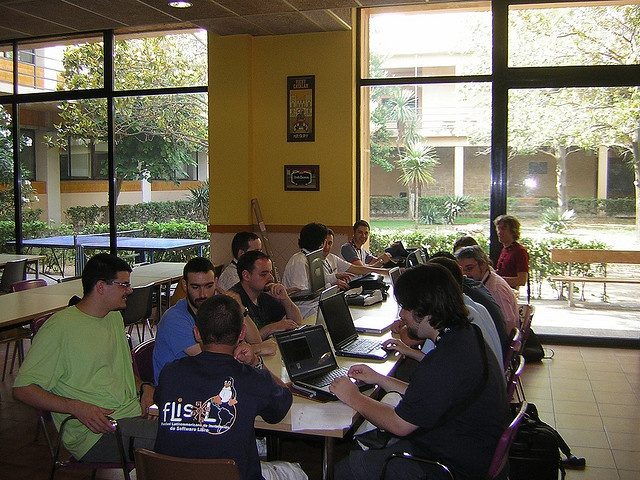Describe the objects in this image and their specific colors. I can see people in black, brown, and gray tones, people in black, olive, maroon, and darkgreen tones, people in black, gray, maroon, and darkgray tones, people in black, navy, and maroon tones, and people in black, maroon, and brown tones in this image. 